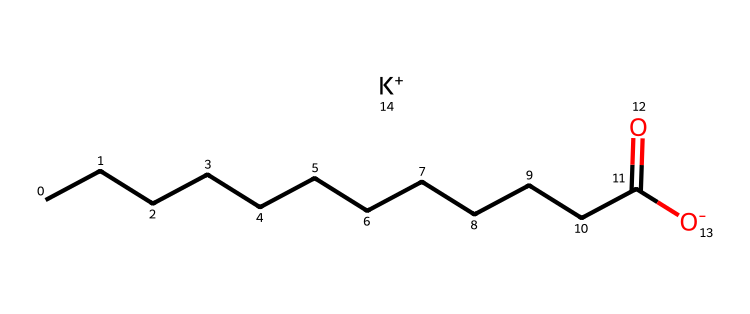What is the molecular formula of potassium cocoate? The molecular formula can be derived from the SMILES notation by identifying the components. The carbon chain (C) indicates there are 12 carbon atoms from "CCCCCCCCCCCC", and potassium (K) is explicitly mentioned at the end of the SMILES. The presence of the carboxylate (-COO-) indicates oxygen (O) atoms are present. Putting this together gives C12H23O2K.
Answer: C12H23O2K How many carbon atoms are present in potassium cocoate? By counting the 'C's in the SMILES notation, we find there are 12 carbon atoms mentioned at the beginning (CCCCCCCCCCCC).
Answer: 12 What type of functional group is present in potassium cocoate? The structure includes a carboxylate group (-COO-) as indicated by "(=O)[O-]" which signifies the presence of a carboxylate ion, a common functional group in soaps and detergents.
Answer: carboxylate What is the charge of the potassium ion in this compound? The notation "[K+]" shows that the potassium ion has a positive charge, signifying it is cationic in nature and balances the anionic part from the carboxylate group.
Answer: +1 What is the total number of oxygen atoms in potassium cocoate? The part "=O" indicates one carbonyl oxygen and the "[O-]" indicates another oxygen. This means there are a total of two oxygen atoms present in the structure.
Answer: 2 Does potassium cocoate contain any double bonds? In the SMILES notation, there is a double bond indicated by "(=O)", which refers to the carbonyl group in the carboxylate part of the molecule. Hence, a double bond is present.
Answer: yes 